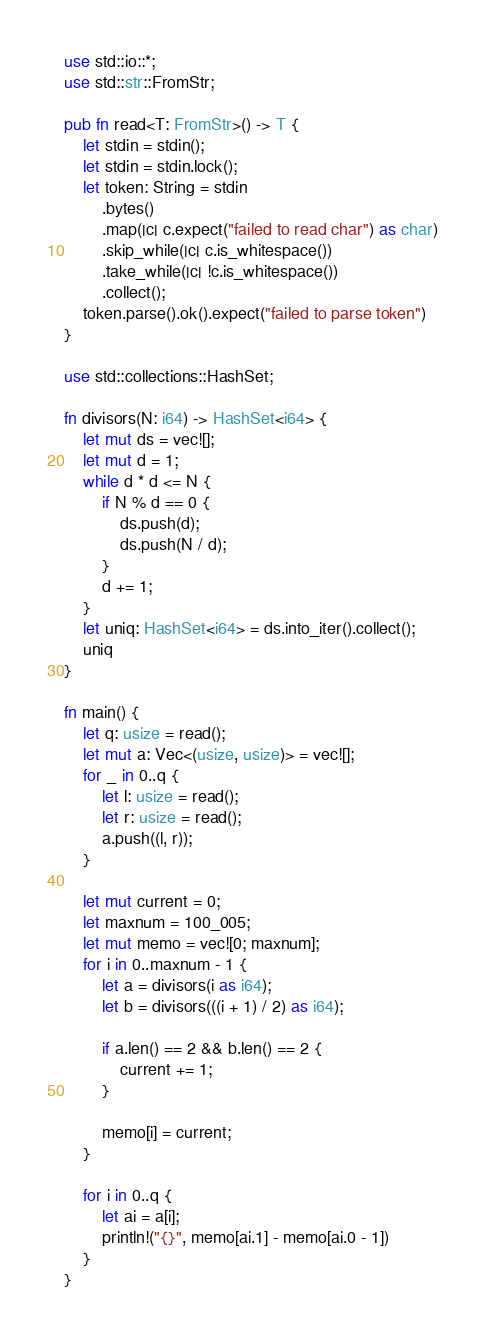<code> <loc_0><loc_0><loc_500><loc_500><_Rust_>use std::io::*;
use std::str::FromStr;

pub fn read<T: FromStr>() -> T {
    let stdin = stdin();
    let stdin = stdin.lock();
    let token: String = stdin
        .bytes()
        .map(|c| c.expect("failed to read char") as char)
        .skip_while(|c| c.is_whitespace())
        .take_while(|c| !c.is_whitespace())
        .collect();
    token.parse().ok().expect("failed to parse token")
}

use std::collections::HashSet;

fn divisors(N: i64) -> HashSet<i64> {
    let mut ds = vec![];
    let mut d = 1;
    while d * d <= N {
        if N % d == 0 {
            ds.push(d);
            ds.push(N / d);
        }
        d += 1;
    }
    let uniq: HashSet<i64> = ds.into_iter().collect();
    uniq
}

fn main() {
    let q: usize = read();
    let mut a: Vec<(usize, usize)> = vec![];
    for _ in 0..q {
        let l: usize = read();
        let r: usize = read();
        a.push((l, r));
    }

    let mut current = 0;
    let maxnum = 100_005;
    let mut memo = vec![0; maxnum];
    for i in 0..maxnum - 1 {
        let a = divisors(i as i64);
        let b = divisors(((i + 1) / 2) as i64);

        if a.len() == 2 && b.len() == 2 {
            current += 1;
        }

        memo[i] = current;
    }

    for i in 0..q {
        let ai = a[i];
        println!("{}", memo[ai.1] - memo[ai.0 - 1])
    }
}
</code> 